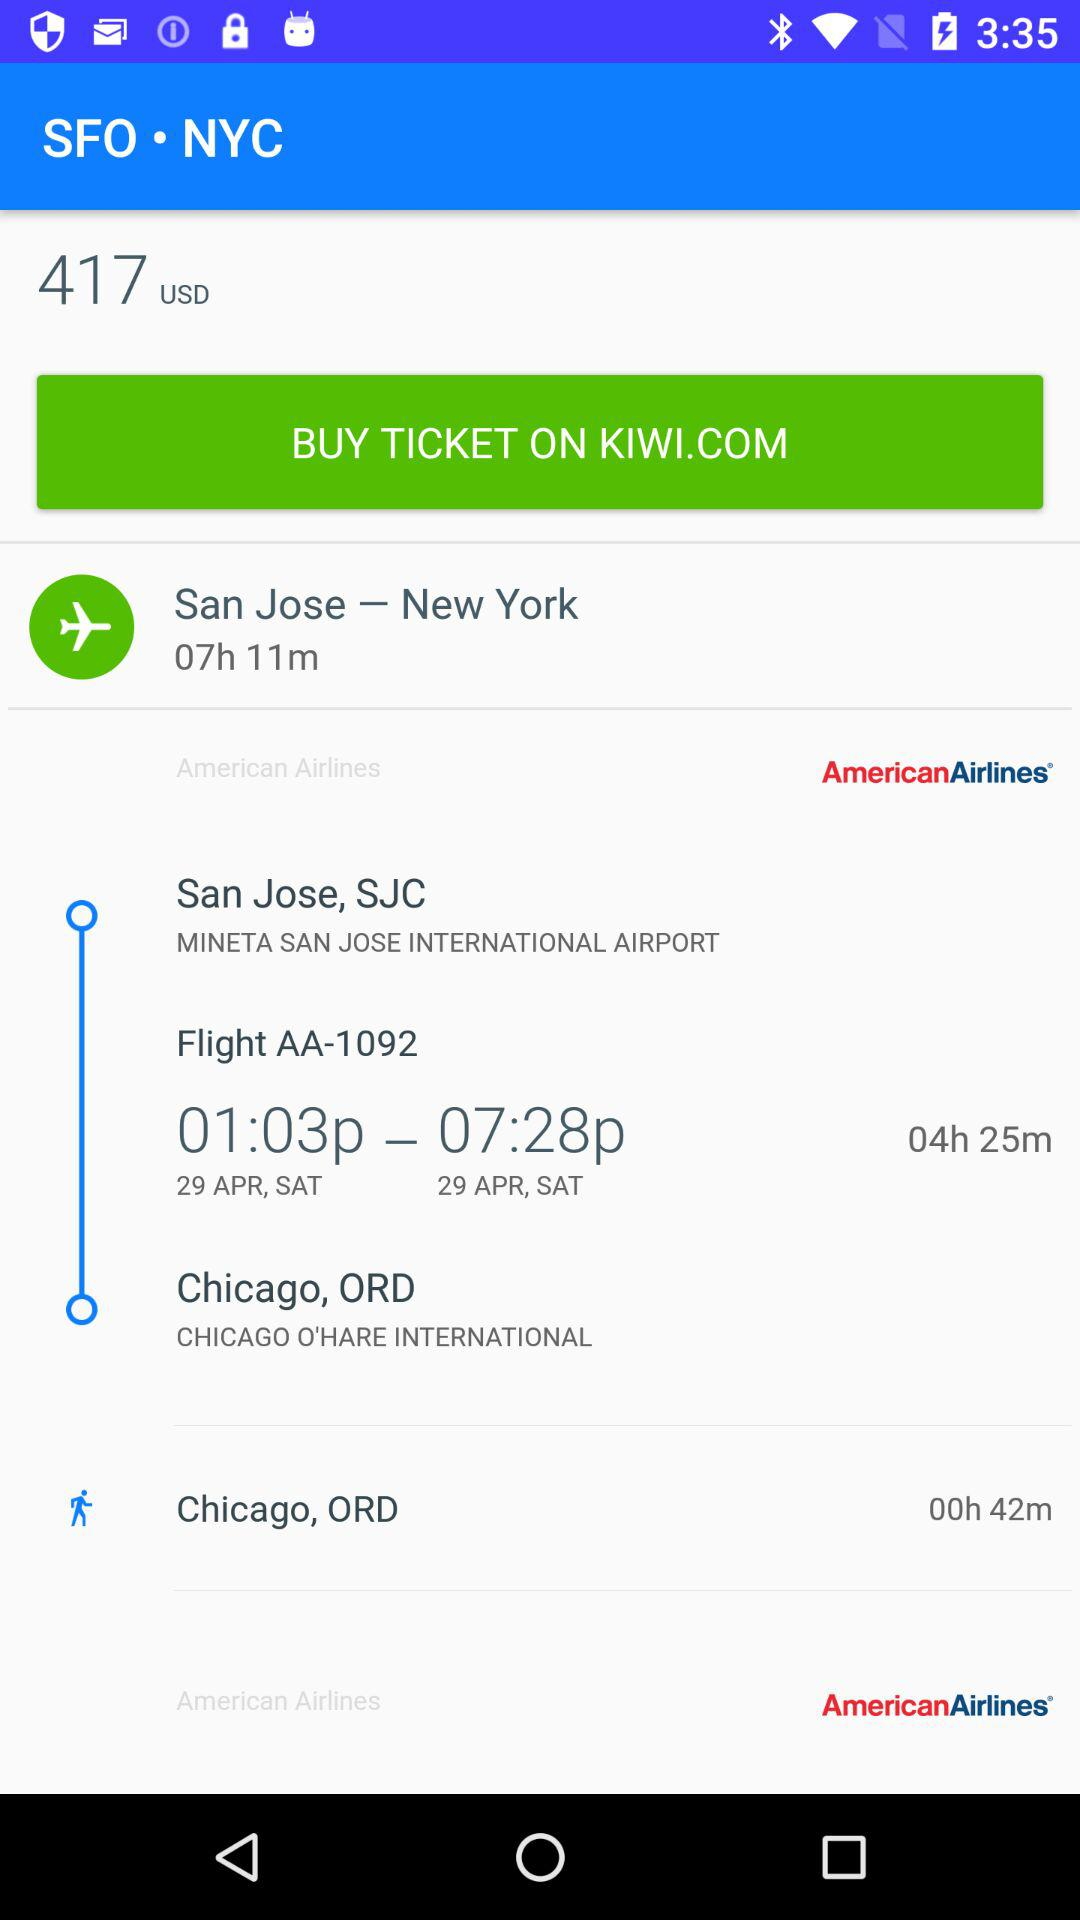What is the airport name? The airport names are Mineta San Jose International Airport and Chicago O'Hare International Airport. 